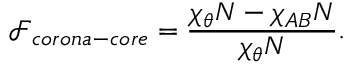<formula> <loc_0><loc_0><loc_500><loc_500>\mathcal { F } _ { c o r o n a - c o r e } = \frac { \chi _ { \theta } N - \chi _ { A B } N } { \chi _ { \theta } N } .</formula> 